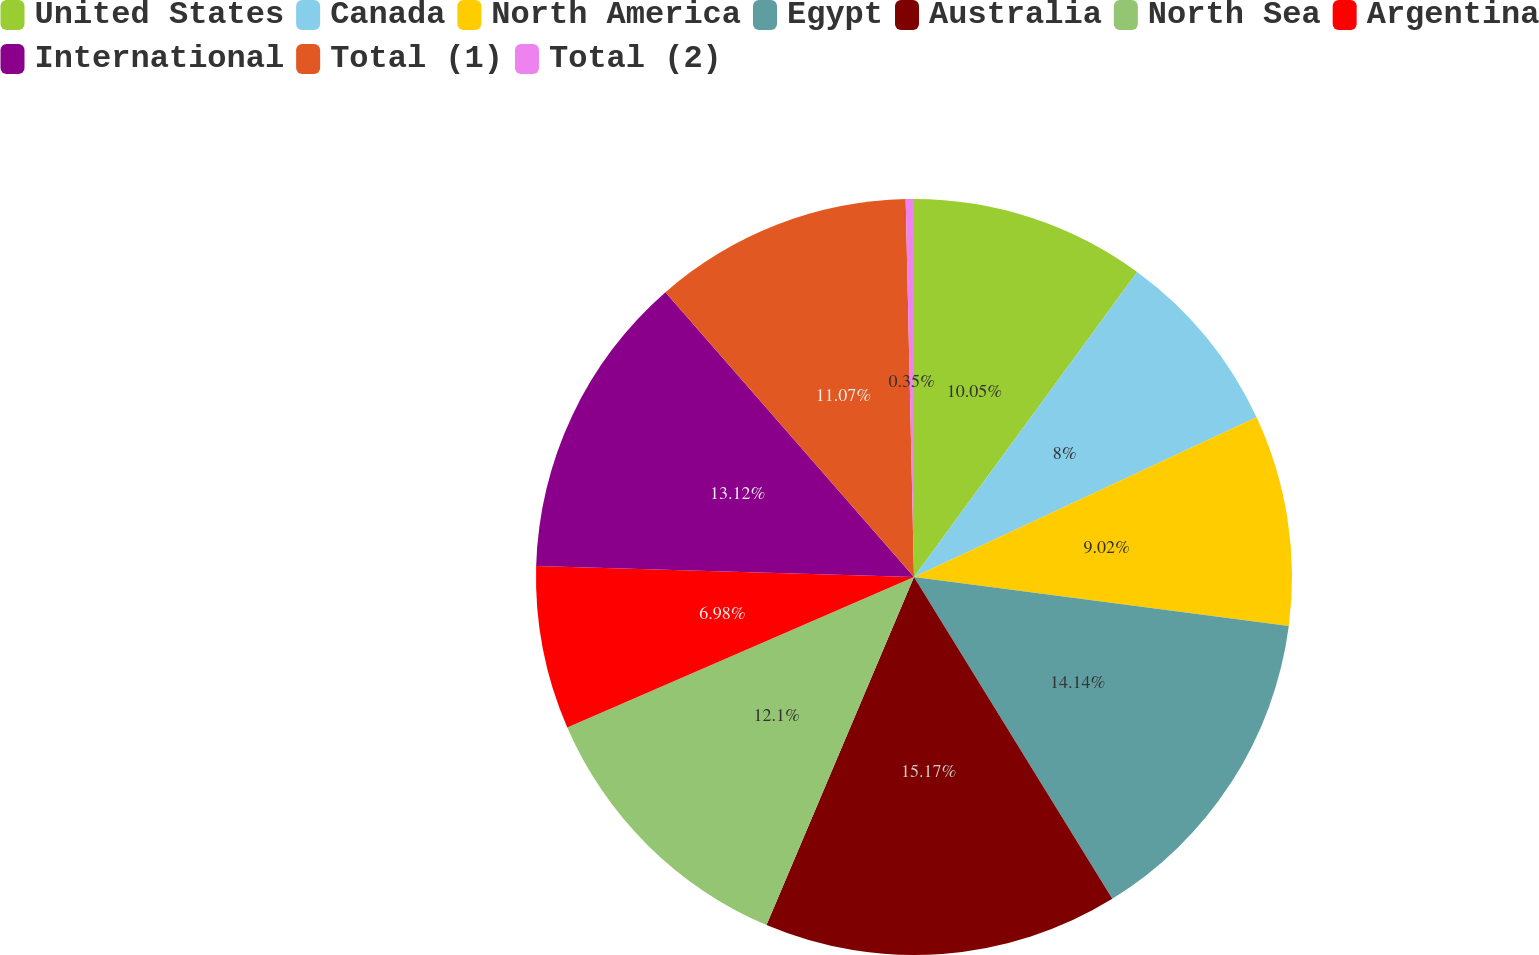Convert chart. <chart><loc_0><loc_0><loc_500><loc_500><pie_chart><fcel>United States<fcel>Canada<fcel>North America<fcel>Egypt<fcel>Australia<fcel>North Sea<fcel>Argentina<fcel>International<fcel>Total (1)<fcel>Total (2)<nl><fcel>10.05%<fcel>8.0%<fcel>9.02%<fcel>14.14%<fcel>15.17%<fcel>12.1%<fcel>6.98%<fcel>13.12%<fcel>11.07%<fcel>0.35%<nl></chart> 